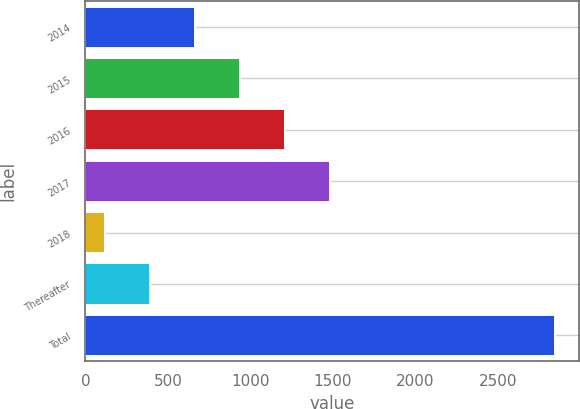Convert chart. <chart><loc_0><loc_0><loc_500><loc_500><bar_chart><fcel>2014<fcel>2015<fcel>2016<fcel>2017<fcel>2018<fcel>Thereafter<fcel>Total<nl><fcel>665.4<fcel>938.1<fcel>1210.8<fcel>1483.5<fcel>120<fcel>392.7<fcel>2847<nl></chart> 